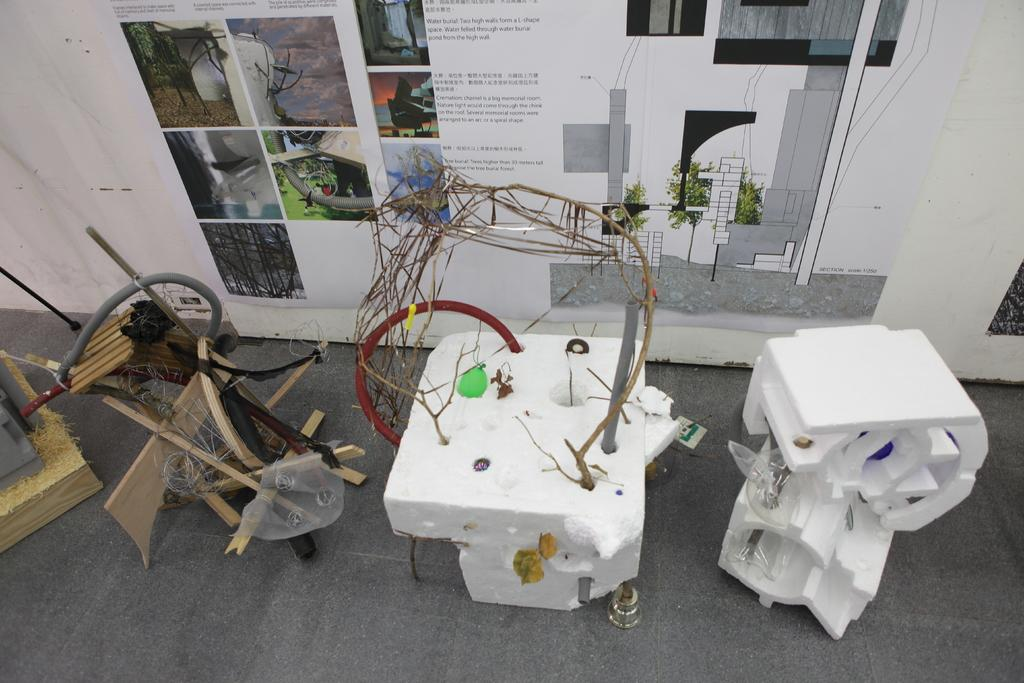What type of materials are used for the objects in the image? There are wooden and thermocol objects in the image. What can be seen on the wall in the image? There is a poster on the wall in the image. What is featured on the poster? The poster contains text and pictures of trees. What type of territory is depicted in the image? There is no territory depicted in the image; it features wooden and thermocol objects, a poster on the wall, and pictures of trees on the poster. What color of paint is used on the volleyball in the image? There is no volleyball present in the image. 